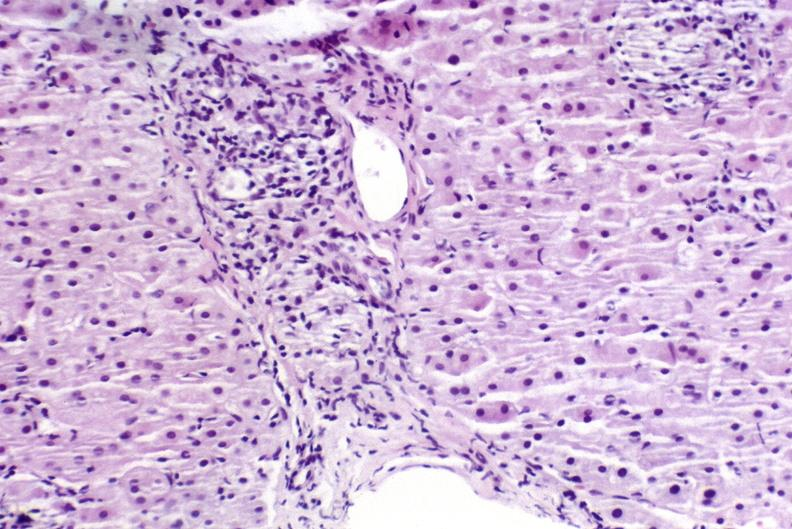what is present?
Answer the question using a single word or phrase. Hepatobiliary 